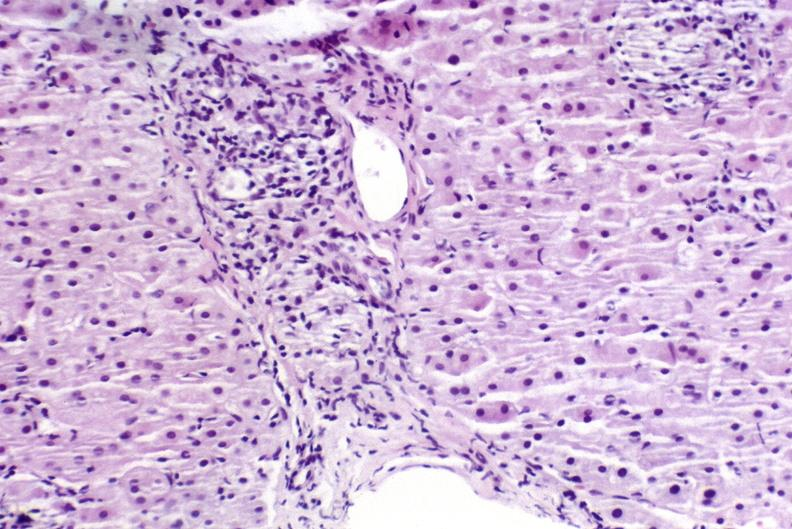what is present?
Answer the question using a single word or phrase. Hepatobiliary 